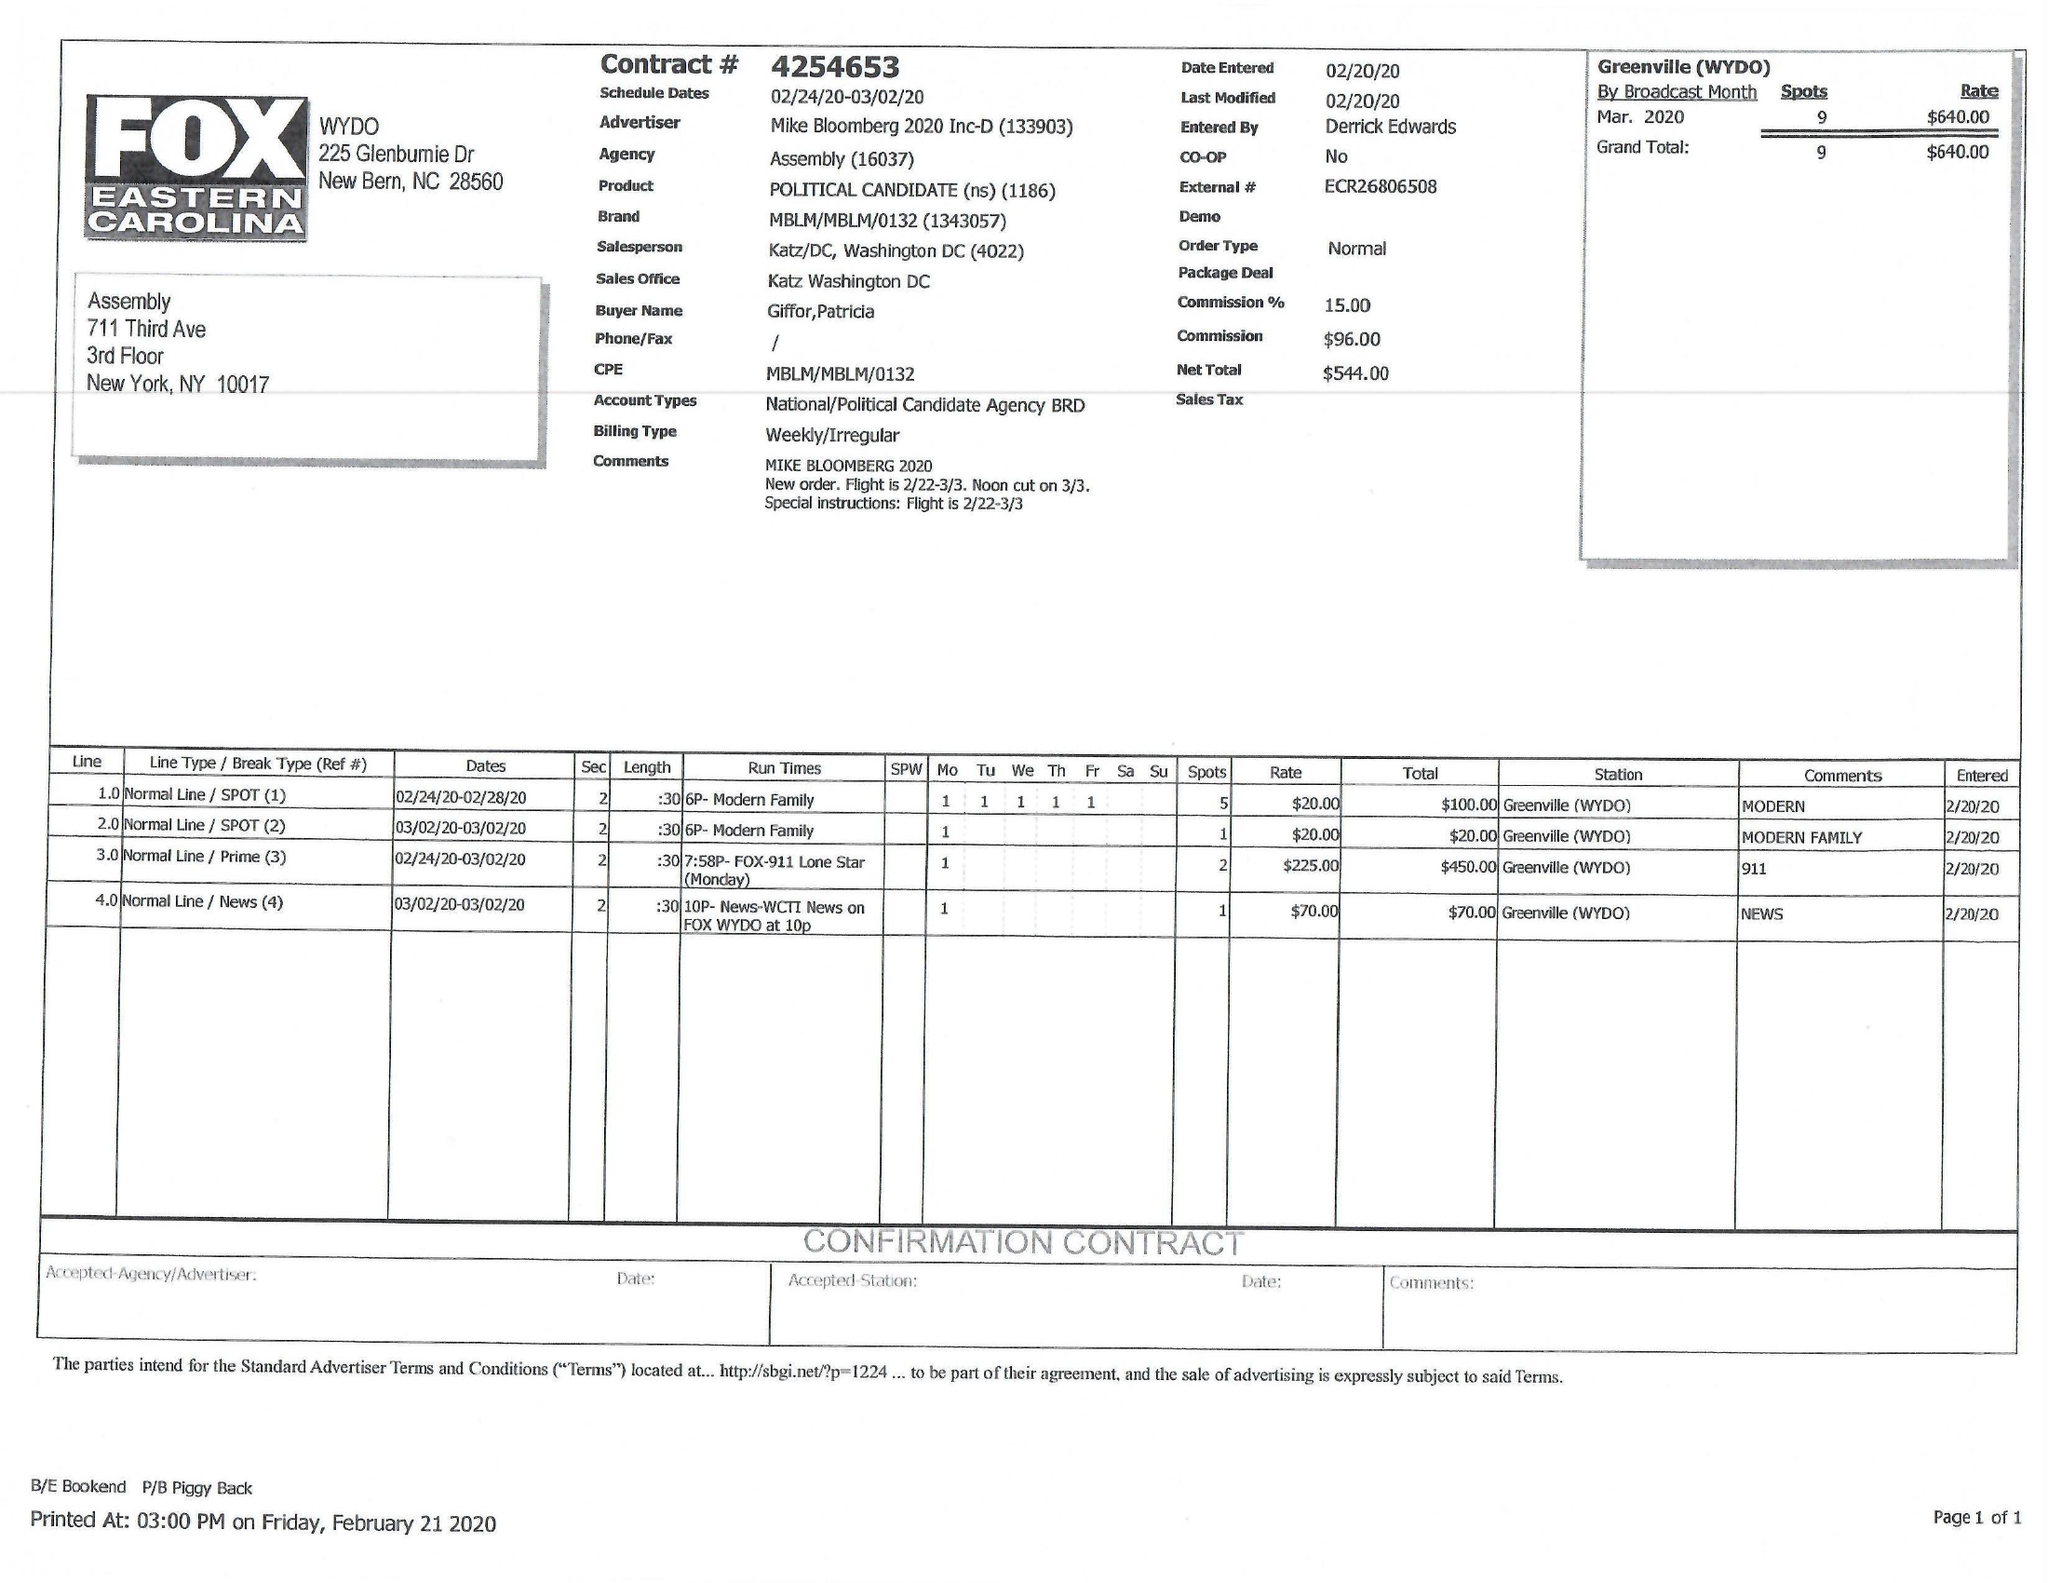What is the value for the advertiser?
Answer the question using a single word or phrase. MIKE BLOOMBERG 2020 INC-D 